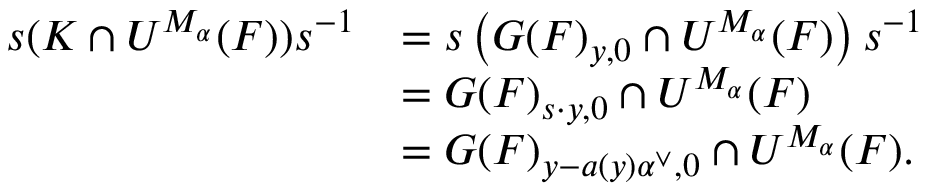<formula> <loc_0><loc_0><loc_500><loc_500>\begin{array} { r l } { s ( K \cap U ^ { M _ { \alpha } } ( F ) ) s ^ { - 1 } } & { = s \left ( G ( F ) _ { y , 0 } \cap U ^ { M _ { \alpha } } ( F ) \right ) s ^ { - 1 } } \\ & { = G ( F ) _ { s \cdot y , 0 } \cap U ^ { M _ { \alpha } } ( F ) } \\ & { = G ( F ) _ { y - a ( y ) \alpha ^ { \vee } , 0 } \cap U ^ { M _ { \alpha } } ( F ) . } \end{array}</formula> 